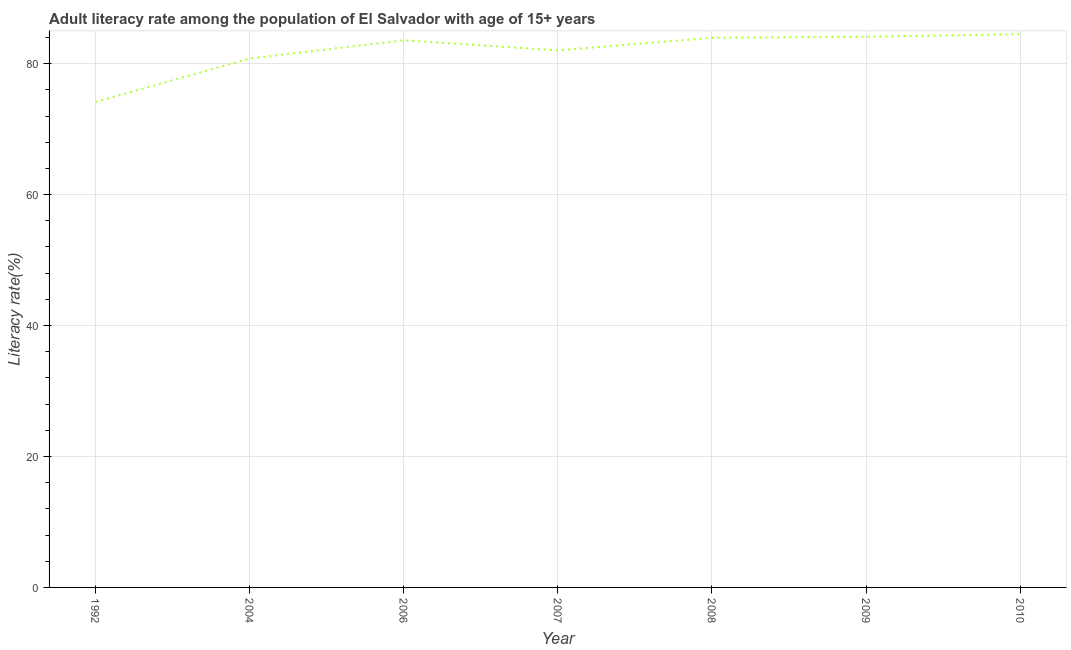What is the adult literacy rate in 2007?
Ensure brevity in your answer.  82.03. Across all years, what is the maximum adult literacy rate?
Offer a very short reply. 84.49. Across all years, what is the minimum adult literacy rate?
Give a very brief answer. 74.14. In which year was the adult literacy rate maximum?
Your response must be concise. 2010. What is the sum of the adult literacy rate?
Offer a very short reply. 573.06. What is the difference between the adult literacy rate in 2004 and 2009?
Keep it short and to the point. -3.32. What is the average adult literacy rate per year?
Your answer should be compact. 81.87. What is the median adult literacy rate?
Offer a terse response. 83.56. In how many years, is the adult literacy rate greater than 28 %?
Provide a succinct answer. 7. Do a majority of the years between 2004 and 2007 (inclusive) have adult literacy rate greater than 32 %?
Provide a short and direct response. Yes. What is the ratio of the adult literacy rate in 2006 to that in 2009?
Offer a very short reply. 0.99. Is the adult literacy rate in 2004 less than that in 2006?
Your answer should be compact. Yes. What is the difference between the highest and the second highest adult literacy rate?
Offer a terse response. 0.39. Is the sum of the adult literacy rate in 1992 and 2004 greater than the maximum adult literacy rate across all years?
Keep it short and to the point. Yes. What is the difference between the highest and the lowest adult literacy rate?
Offer a terse response. 10.35. In how many years, is the adult literacy rate greater than the average adult literacy rate taken over all years?
Give a very brief answer. 5. Does the adult literacy rate monotonically increase over the years?
Your answer should be very brief. No. How many years are there in the graph?
Offer a very short reply. 7. What is the difference between two consecutive major ticks on the Y-axis?
Your answer should be very brief. 20. Are the values on the major ticks of Y-axis written in scientific E-notation?
Offer a very short reply. No. Does the graph contain any zero values?
Your response must be concise. No. What is the title of the graph?
Your answer should be compact. Adult literacy rate among the population of El Salvador with age of 15+ years. What is the label or title of the X-axis?
Make the answer very short. Year. What is the label or title of the Y-axis?
Make the answer very short. Literacy rate(%). What is the Literacy rate(%) of 1992?
Ensure brevity in your answer.  74.14. What is the Literacy rate(%) of 2004?
Make the answer very short. 80.78. What is the Literacy rate(%) of 2006?
Provide a short and direct response. 83.56. What is the Literacy rate(%) in 2007?
Your answer should be compact. 82.03. What is the Literacy rate(%) in 2008?
Your answer should be compact. 83.95. What is the Literacy rate(%) of 2009?
Provide a short and direct response. 84.1. What is the Literacy rate(%) in 2010?
Make the answer very short. 84.49. What is the difference between the Literacy rate(%) in 1992 and 2004?
Make the answer very short. -6.64. What is the difference between the Literacy rate(%) in 1992 and 2006?
Keep it short and to the point. -9.42. What is the difference between the Literacy rate(%) in 1992 and 2007?
Provide a succinct answer. -7.89. What is the difference between the Literacy rate(%) in 1992 and 2008?
Keep it short and to the point. -9.81. What is the difference between the Literacy rate(%) in 1992 and 2009?
Offer a very short reply. -9.96. What is the difference between the Literacy rate(%) in 1992 and 2010?
Offer a very short reply. -10.35. What is the difference between the Literacy rate(%) in 2004 and 2006?
Give a very brief answer. -2.78. What is the difference between the Literacy rate(%) in 2004 and 2007?
Give a very brief answer. -1.25. What is the difference between the Literacy rate(%) in 2004 and 2008?
Your answer should be very brief. -3.17. What is the difference between the Literacy rate(%) in 2004 and 2009?
Offer a terse response. -3.32. What is the difference between the Literacy rate(%) in 2004 and 2010?
Your answer should be very brief. -3.71. What is the difference between the Literacy rate(%) in 2006 and 2007?
Give a very brief answer. 1.53. What is the difference between the Literacy rate(%) in 2006 and 2008?
Your response must be concise. -0.39. What is the difference between the Literacy rate(%) in 2006 and 2009?
Provide a succinct answer. -0.54. What is the difference between the Literacy rate(%) in 2006 and 2010?
Ensure brevity in your answer.  -0.93. What is the difference between the Literacy rate(%) in 2007 and 2008?
Make the answer very short. -1.92. What is the difference between the Literacy rate(%) in 2007 and 2009?
Ensure brevity in your answer.  -2.07. What is the difference between the Literacy rate(%) in 2007 and 2010?
Your answer should be compact. -2.46. What is the difference between the Literacy rate(%) in 2008 and 2009?
Make the answer very short. -0.15. What is the difference between the Literacy rate(%) in 2008 and 2010?
Your answer should be compact. -0.54. What is the difference between the Literacy rate(%) in 2009 and 2010?
Offer a very short reply. -0.39. What is the ratio of the Literacy rate(%) in 1992 to that in 2004?
Provide a short and direct response. 0.92. What is the ratio of the Literacy rate(%) in 1992 to that in 2006?
Make the answer very short. 0.89. What is the ratio of the Literacy rate(%) in 1992 to that in 2007?
Ensure brevity in your answer.  0.9. What is the ratio of the Literacy rate(%) in 1992 to that in 2008?
Make the answer very short. 0.88. What is the ratio of the Literacy rate(%) in 1992 to that in 2009?
Ensure brevity in your answer.  0.88. What is the ratio of the Literacy rate(%) in 1992 to that in 2010?
Offer a very short reply. 0.88. What is the ratio of the Literacy rate(%) in 2004 to that in 2006?
Ensure brevity in your answer.  0.97. What is the ratio of the Literacy rate(%) in 2004 to that in 2008?
Give a very brief answer. 0.96. What is the ratio of the Literacy rate(%) in 2004 to that in 2009?
Your response must be concise. 0.96. What is the ratio of the Literacy rate(%) in 2004 to that in 2010?
Make the answer very short. 0.96. What is the ratio of the Literacy rate(%) in 2006 to that in 2007?
Make the answer very short. 1.02. What is the ratio of the Literacy rate(%) in 2006 to that in 2009?
Make the answer very short. 0.99. What is the ratio of the Literacy rate(%) in 2007 to that in 2008?
Provide a succinct answer. 0.98. What is the ratio of the Literacy rate(%) in 2007 to that in 2009?
Provide a succinct answer. 0.97. What is the ratio of the Literacy rate(%) in 2007 to that in 2010?
Your response must be concise. 0.97. What is the ratio of the Literacy rate(%) in 2008 to that in 2009?
Your answer should be compact. 1. What is the ratio of the Literacy rate(%) in 2008 to that in 2010?
Your response must be concise. 0.99. What is the ratio of the Literacy rate(%) in 2009 to that in 2010?
Your answer should be very brief. 0.99. 